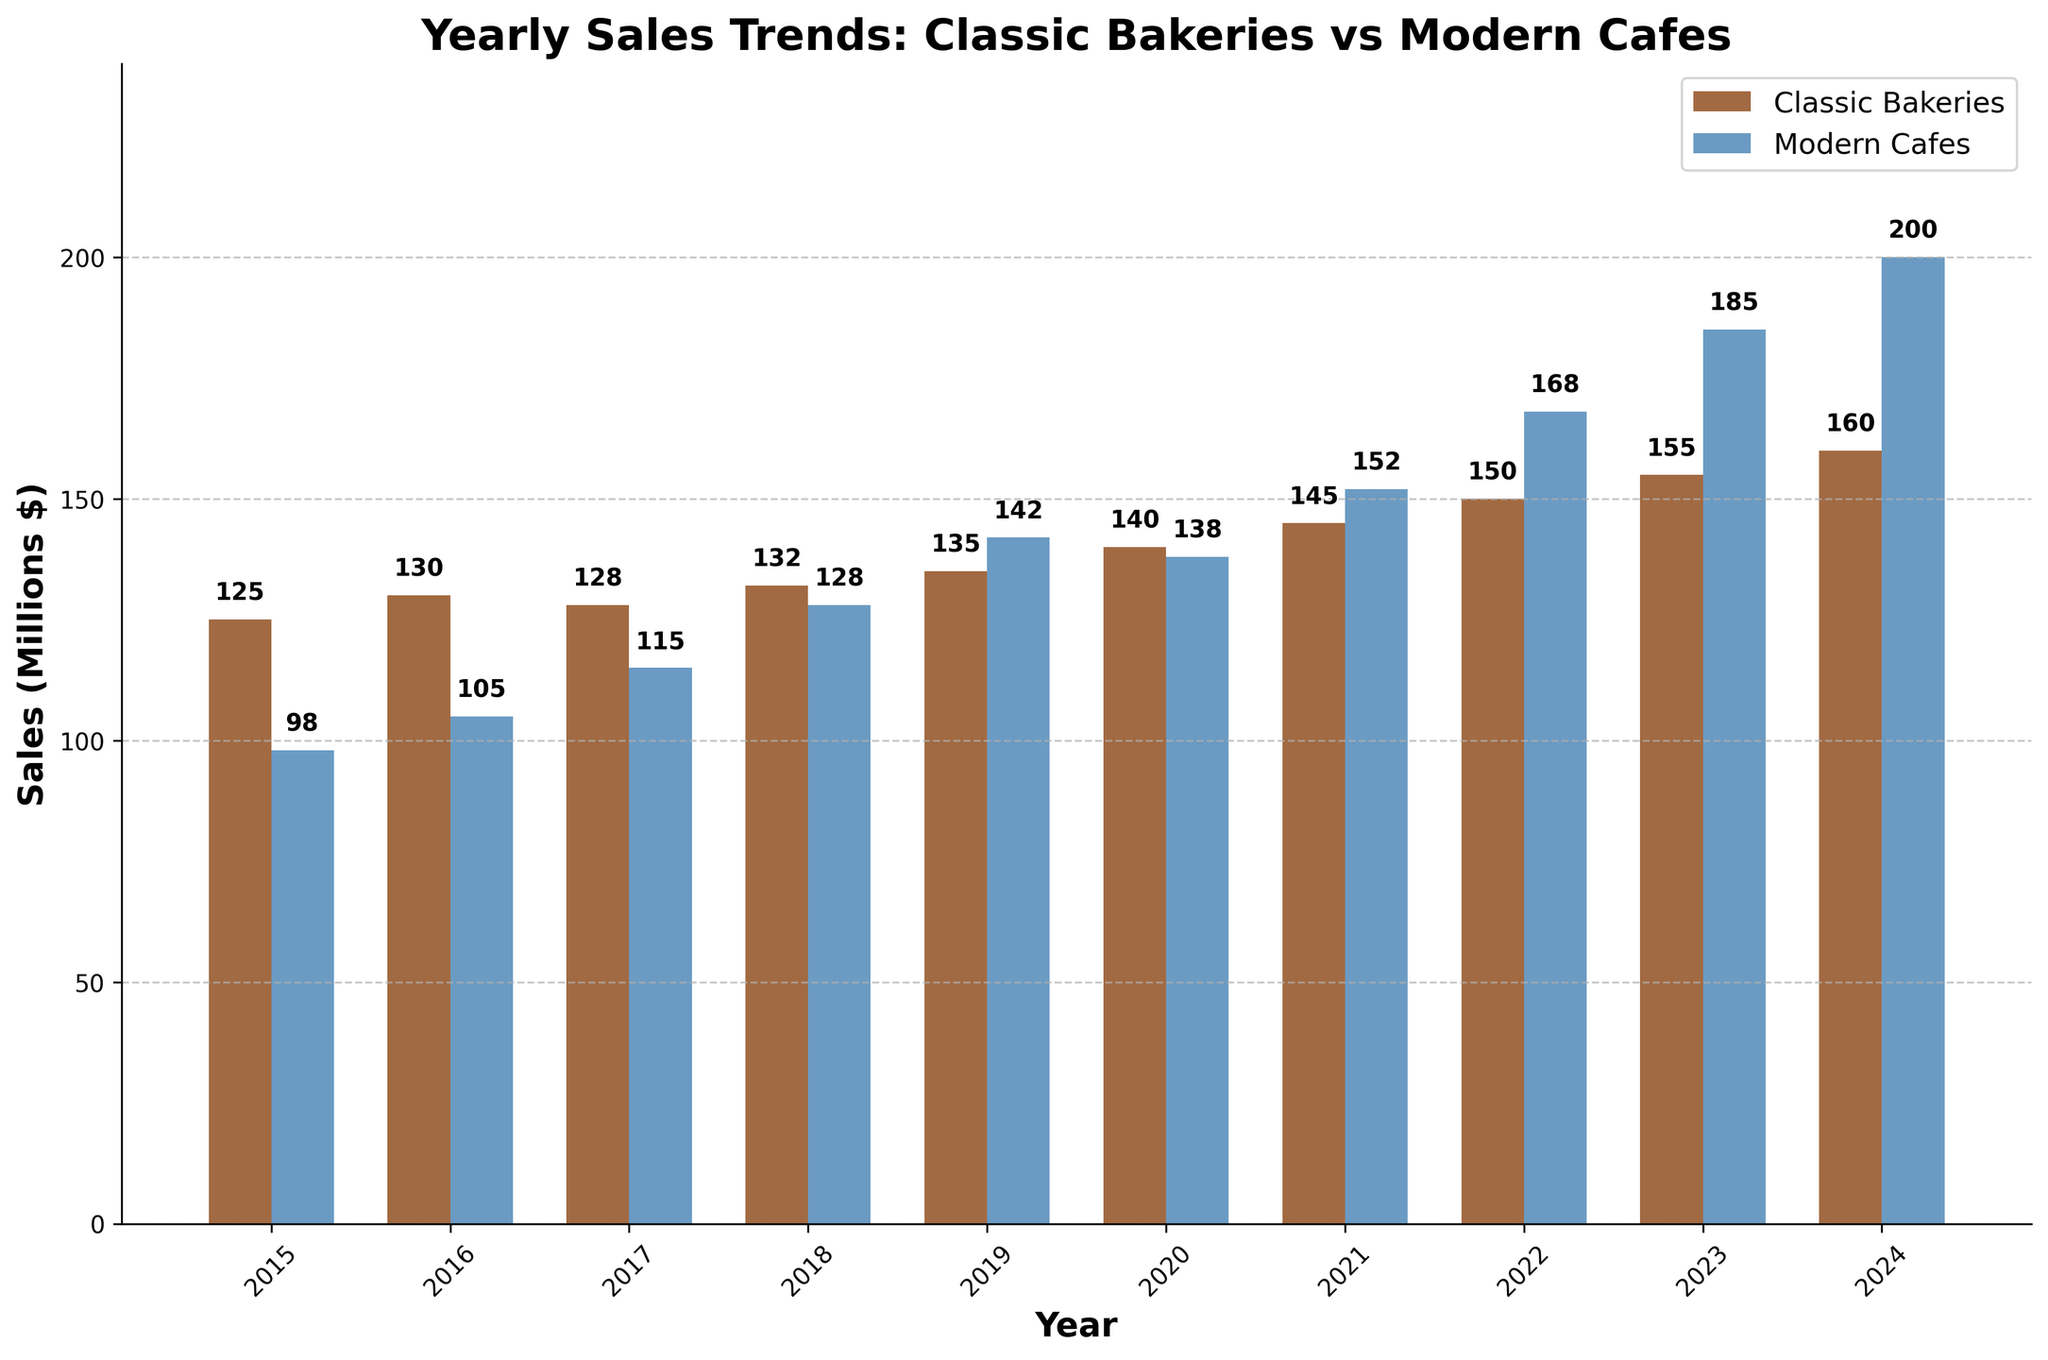What is the overall trend for sales in Classic Bakeries from 2015 to 2024? Over the years shown, the sales for Classic Bakeries display an upward trend. Each subsequent year shows an increase over the previous year, starting from 125 million in 2015 and reaching 160 million in 2024.
Answer: Upward trend Which year did Modern Cafes sales first surpass Classic Bakeries sales? By comparing the sales values year by year, we see that Modern Cafes sales first surpassed Classic Bakeries sales in 2019, where Modern Cafes sales were 142 million compared to Classic Bakeries sales of 135 million.
Answer: 2019 What's the difference in sales between Classic Bakeries and Modern Cafes in the year 2023? The sales for Classic Bakeries in 2023 are 155 million, and for Modern Cafes, it is 185 million. The difference can be calculated as 185M - 155M, resulting in 30 million.
Answer: 30 million Over these years, which type of establishment shows a higher average annual sales growth rate? First, calculate each year's sales growth. Then, find the average for both types. Classic Bakeries grow from 125M to 160M over 10 years, averaging ((160-125)/10) = 3.5M per year. Modern Cafes grow from 98M to 200M, averaging ((200-98)/10) = 10.2M per year. Thus, Modern Cafes have a higher average annual sales growth rate.
Answer: Modern Cafes How much did Modern Cafes sales increase from 2016 to 2022? Modern Cafes sales in 2016 were 105 million, and in 2022 they were 168 million. The increase is calculated as 168M - 105M = 63 million.
Answer: 63 million Which establishment had higher sales in 2020, and by how much? In 2020, Classic Bakeries had sales of 140 million, and Modern Cafes had sales of 138 million. Comparing these, Classic Bakeries had higher sales. The difference is 140M - 138M = 2 million.
Answer: Classic Bakeries by 2 million In what year does Classic Bakeries sales reach 150 million? Referring to the bar heights, Classic Bakeries sales reach exactly 150 million in the year 2022.
Answer: 2022 Are there any years where the sales for both Classic Bakeries and Modern Cafes are equal? By examining each year's sales, there is no year where the sales figures for Classic Bakeries and Modern Cafes are the same.
Answer: No Which year had the smallest gap between the sales of Classic Bakeries and Modern Cafes? By comparing the difference in sales each year, the smallest gap can be spot-checked. In 2020, the sales difference was the smallest, 140M (Classic) vs. 138M (Modern), resulting in a 2 million gap.
Answer: 2020 What is the color used for Classic Bakeries in the bar chart? The Classic Bakeries bars are colored in a brown shade, specifically mentioned as '#8B4513'.
Answer: Brown 